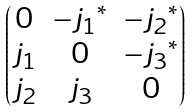Convert formula to latex. <formula><loc_0><loc_0><loc_500><loc_500>\begin{pmatrix} 0 & - { j _ { 1 } } ^ { * } & - { j _ { 2 } } ^ { * } \\ j _ { 1 } & 0 & - { j _ { 3 } } ^ { * } \\ j _ { 2 } & j _ { 3 } & 0 \end{pmatrix}</formula> 